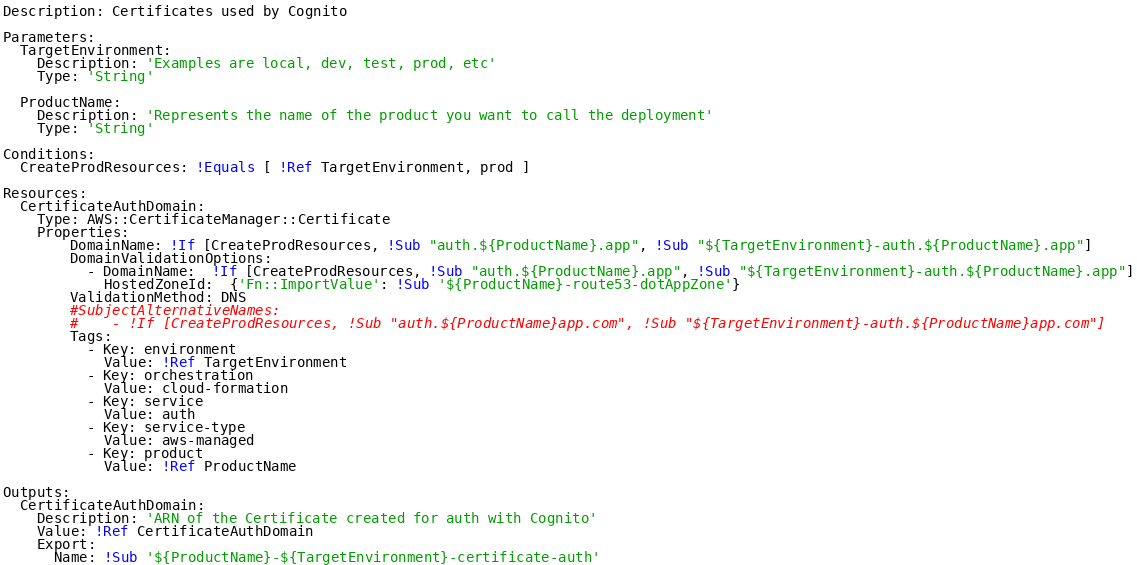<code> <loc_0><loc_0><loc_500><loc_500><_YAML_>Description: Certificates used by Cognito

Parameters:
  TargetEnvironment:
    Description: 'Examples are local, dev, test, prod, etc'
    Type: 'String'
    
  ProductName:
    Description: 'Represents the name of the product you want to call the deployment'
    Type: 'String'

Conditions: 
  CreateProdResources: !Equals [ !Ref TargetEnvironment, prod ]
  
Resources:
  CertificateAuthDomain:
    Type: AWS::CertificateManager::Certificate
    Properties:
        DomainName: !If [CreateProdResources, !Sub "auth.${ProductName}.app", !Sub "${TargetEnvironment}-auth.${ProductName}.app"]
        DomainValidationOptions:
          - DomainName:  !If [CreateProdResources, !Sub "auth.${ProductName}.app", !Sub "${TargetEnvironment}-auth.${ProductName}.app"]
            HostedZoneId:  {'Fn::ImportValue': !Sub '${ProductName}-route53-dotAppZone'}
        ValidationMethod: DNS
        #SubjectAlternativeNames:
        #    - !If [CreateProdResources, !Sub "auth.${ProductName}app.com", !Sub "${TargetEnvironment}-auth.${ProductName}app.com"]
        Tags:
          - Key: environment
            Value: !Ref TargetEnvironment
          - Key: orchestration
            Value: cloud-formation
          - Key: service
            Value: auth
          - Key: service-type
            Value: aws-managed
          - Key: product
            Value: !Ref ProductName
          
Outputs:
  CertificateAuthDomain:
    Description: 'ARN of the Certificate created for auth with Cognito'
    Value: !Ref CertificateAuthDomain
    Export:
      Name: !Sub '${ProductName}-${TargetEnvironment}-certificate-auth'</code> 